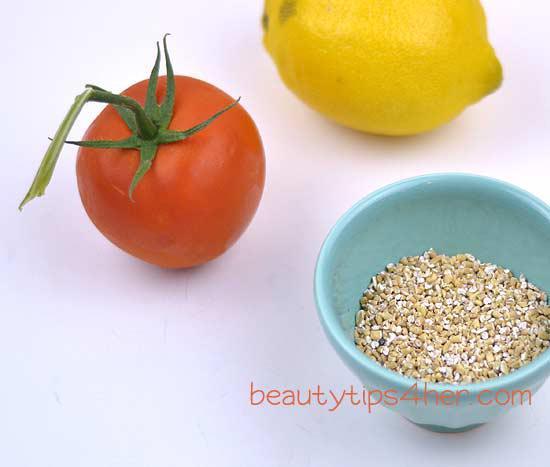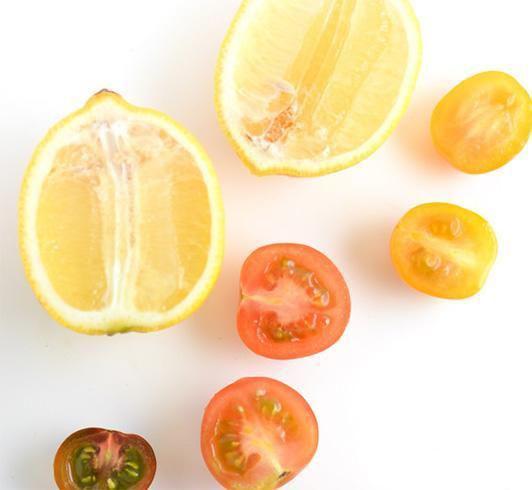The first image is the image on the left, the second image is the image on the right. Examine the images to the left and right. Is the description "There is a whole un cut tomato next to lemon and whole turmeric root which is next to the powdered turmeric" accurate? Answer yes or no. No. The first image is the image on the left, the second image is the image on the right. Examine the images to the left and right. Is the description "The left image includes at least one whole tomato and whole lemon, and exactly one bowl of grain." accurate? Answer yes or no. Yes. 